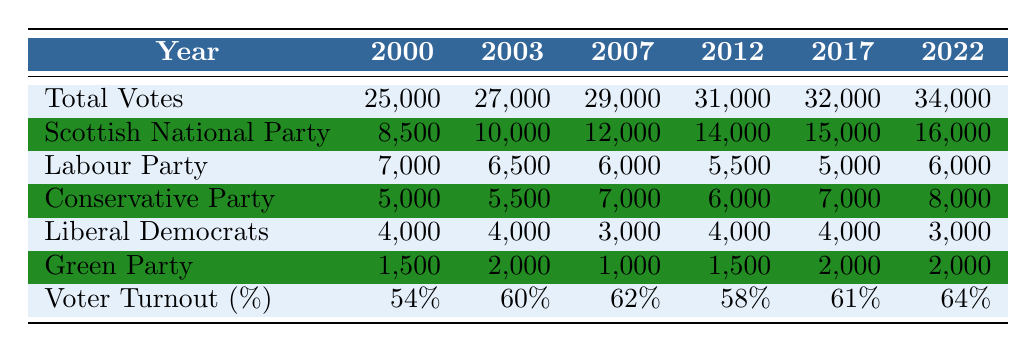What was the total number of votes in 2007? The table lists the total votes for the year 2007 as 29,000.
Answer: 29,000 Which party received the highest number of votes in 2012? Looking at the party votes for 2012, the Scottish National Party received 14,000 votes, which is more than any other party.
Answer: Scottish National Party What is the total voter turnout percentage for the elections from 2000 to 2022? The turnout percentages are 54, 60, 62, 58, 61, and 64. Adding these gives a total of 319. To find the average, divide by the number of elections (6), which results in approximately 53.17.
Answer: 53.17 Did the Conservative Party receive more votes in 2022 than in 2017? The Conservative Party received 8,000 votes in 2022 and 7,000 in 2017. Since 8,000 is greater than 7,000, the statement is true.
Answer: Yes Which party showed a consistent increase in votes from 2000 to 2022? The Scottish National Party showed a consistent increase: 8,500 in 2000, 10,000 in 2003, 12,000 in 2007, 14,000 in 2012, 15,000 in 2017, and 16,000 in 2022.
Answer: Scottish National Party What is the difference in voter turnout between 2000 and 2022? In 2000, the voter turnout was 54%, and in 2022 it was 64%. The difference is 64 - 54 = 10 percentage points.
Answer: 10 Is the total number of votes in 2017 greater than both 2003 and 2000 combined? The total votes in 2017 were 32,000, while the sum of total votes in 2003 (27,000) and 2000 (25,000) is 52,000. Since 32,000 is less than 52,000, the statement is false.
Answer: No Which party had the lowest number of votes in 2012 and what was that number? In 2012, the party with the lowest votes was the Green Party, which received 1,500 votes.
Answer: Green Party; 1,500 How many votes did the Labour Party receive in the election year with the highest total votes? The highest total votes were in 2022, where the Labour Party received 6,000 votes.
Answer: 6,000 